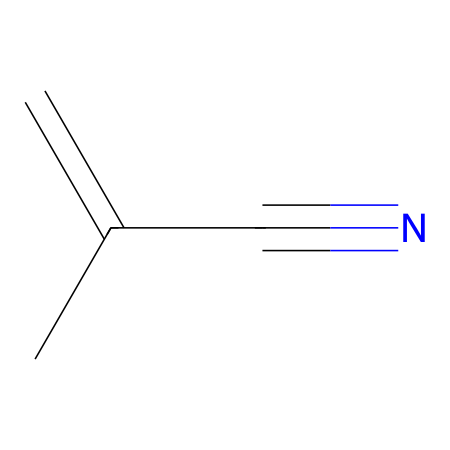What is the name of this chemical? The SMILES representation C=C(C)C#N corresponds to methacrylonitrile, which is derived from methacrylic acid and contains a nitrile functional group.
Answer: methacrylonitrile How many carbon atoms are in methacrylonitrile? By analyzing the SMILES, we can see three distinct carbon atoms are represented in the structure, including the two in the double bond and one in the side group.
Answer: three What functional group is present in this chemical? The presence of the #N component in the SMILES indicates a nitrile functional group, which is characterized by a carbon triple-bonded to a nitrogen atom.
Answer: nitrile What is the carbon-to-nitrogen ratio? There are three carbon atoms and one nitrogen atom present in methacrylonitrile, leading to a carbon-to-nitrogen ratio of three to one.
Answer: three to one Why is methacrylonitrile significant in prosthetic applications? Methacrylonitrile is significant because of its adhesive properties, derived from its ability to form strong bonds due to the presence of both the double bond and nitrile group in its structure.
Answer: adhesive properties How many double bonds are present in methacrylonitrile? The SMILES shows a C=C, which indicates one double bond is present between the two carbon atoms.
Answer: one What type of reaction is commonly associated with methacrylonitrile? Methacrylonitrile can undergo polymerization reactions, where it reacts to form long chains, making it useful in industrial applications such as producing plastics and adhesives.
Answer: polymerization 